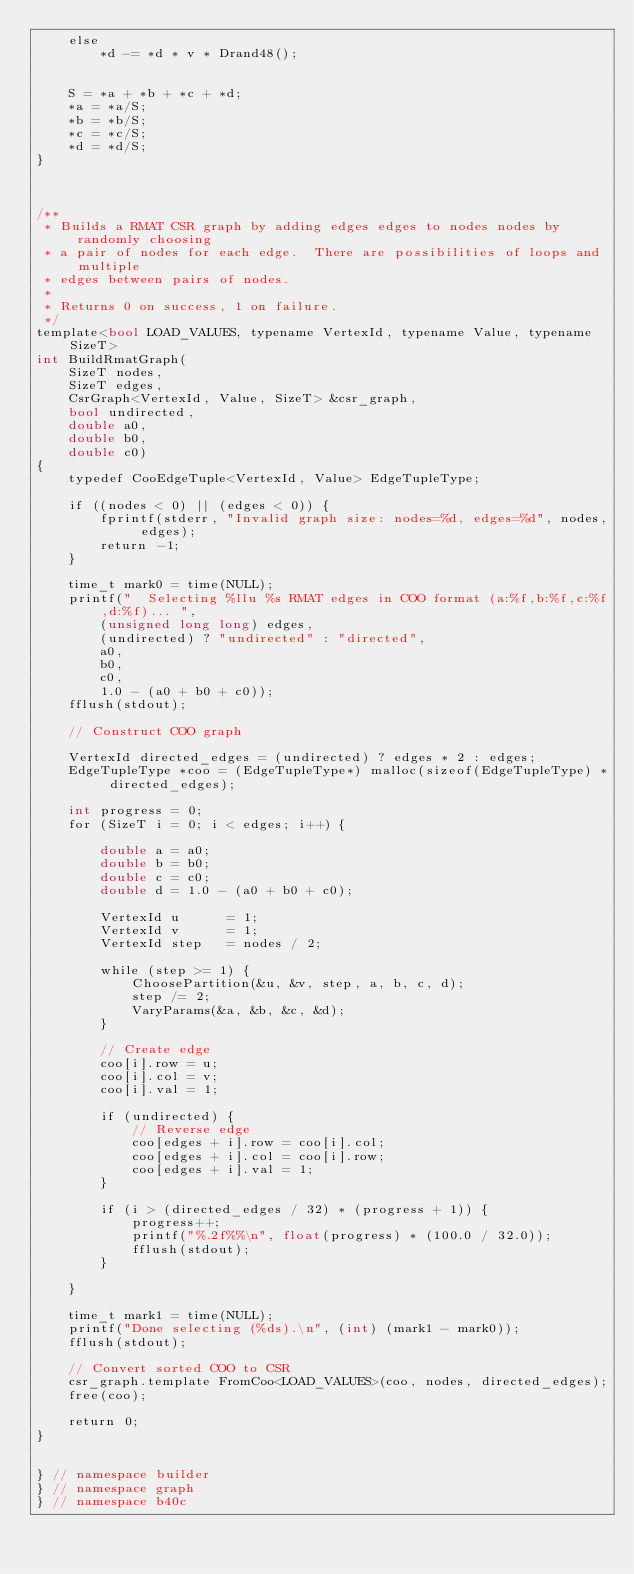<code> <loc_0><loc_0><loc_500><loc_500><_Cuda_>	else
		*d -= *d * v * Drand48();


	S = *a + *b + *c + *d;
	*a = *a/S;
	*b = *b/S;
	*c = *c/S;
	*d = *d/S;
}



/**
 * Builds a RMAT CSR graph by adding edges edges to nodes nodes by randomly choosing
 * a pair of nodes for each edge.  There are possibilities of loops and multiple 
 * edges between pairs of nodes.    
 * 
 * Returns 0 on success, 1 on failure.
 */
template<bool LOAD_VALUES, typename VertexId, typename Value, typename SizeT>
int BuildRmatGraph(
	SizeT nodes,
	SizeT edges,
	CsrGraph<VertexId, Value, SizeT> &csr_graph,
	bool undirected,
	double a0,
	double b0,
	double c0)
{ 
	typedef CooEdgeTuple<VertexId, Value> EdgeTupleType;

	if ((nodes < 0) || (edges < 0)) {
		fprintf(stderr, "Invalid graph size: nodes=%d, edges=%d", nodes, edges);
		return -1;
	}

	time_t mark0 = time(NULL);
	printf("  Selecting %llu %s RMAT edges in COO format (a:%f,b:%f,c:%f,d:%f)... ",
		(unsigned long long) edges,
		(undirected) ? "undirected" : "directed",
		a0,
		b0,
		c0,
		1.0 - (a0 + b0 + c0));
	fflush(stdout);

	// Construct COO graph

	VertexId directed_edges = (undirected) ? edges * 2 : edges;
	EdgeTupleType *coo = (EdgeTupleType*) malloc(sizeof(EdgeTupleType) * directed_edges);

	int progress = 0;
	for (SizeT i = 0; i < edges; i++) {

		double a = a0;
		double b = b0;
		double c = c0;
		double d = 1.0 - (a0 + b0 + c0);

		VertexId u 		= 1;
		VertexId v 		= 1;
		VertexId step 	= nodes / 2;

		while (step >= 1) {
			ChoosePartition(&u, &v, step, a, b, c, d);
			step /= 2;
			VaryParams(&a, &b, &c, &d);
		}

		// Create edge
		coo[i].row = u;
		coo[i].col = v;
		coo[i].val = 1;

		if (undirected) {
			// Reverse edge
			coo[edges + i].row = coo[i].col;
			coo[edges + i].col = coo[i].row;
			coo[edges + i].val = 1;
		}

		if (i > (directed_edges / 32) * (progress + 1)) {
			progress++;
			printf("%.2f%%\n", float(progress) * (100.0 / 32.0));
			fflush(stdout);
		}

	}

	time_t mark1 = time(NULL);
	printf("Done selecting (%ds).\n", (int) (mark1 - mark0));
	fflush(stdout);
	
	// Convert sorted COO to CSR
	csr_graph.template FromCoo<LOAD_VALUES>(coo, nodes, directed_edges);
	free(coo);
	
	return 0;
}


} // namespace builder
} // namespace graph
} // namespace b40c
</code> 